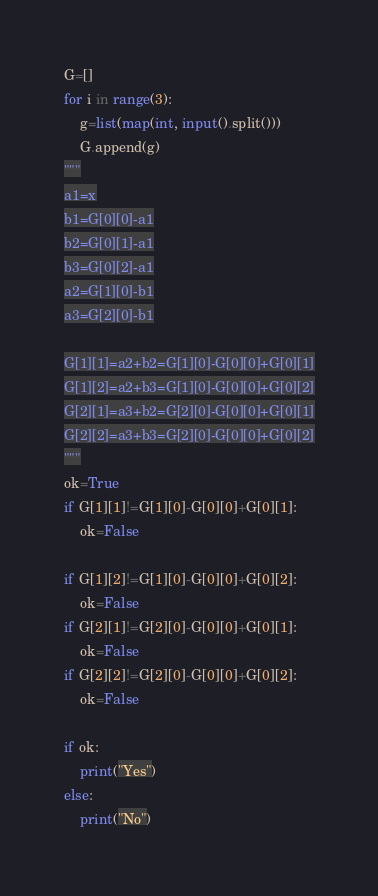<code> <loc_0><loc_0><loc_500><loc_500><_Python_>G=[]
for i in range(3):
    g=list(map(int, input().split()))
    G.append(g)
"""
a1=x
b1=G[0][0]-a1
b2=G[0][1]-a1
b3=G[0][2]-a1
a2=G[1][0]-b1
a3=G[2][0]-b1

G[1][1]=a2+b2=G[1][0]-G[0][0]+G[0][1]
G[1][2]=a2+b3=G[1][0]-G[0][0]+G[0][2]
G[2][1]=a3+b2=G[2][0]-G[0][0]+G[0][1]
G[2][2]=a3+b3=G[2][0]-G[0][0]+G[0][2]
"""
ok=True
if G[1][1]!=G[1][0]-G[0][0]+G[0][1]:
    ok=False

if G[1][2]!=G[1][0]-G[0][0]+G[0][2]:
    ok=False
if G[2][1]!=G[2][0]-G[0][0]+G[0][1]:
    ok=False
if G[2][2]!=G[2][0]-G[0][0]+G[0][2]:
    ok=False

if ok:
    print("Yes")
else:
    print("No")
</code> 